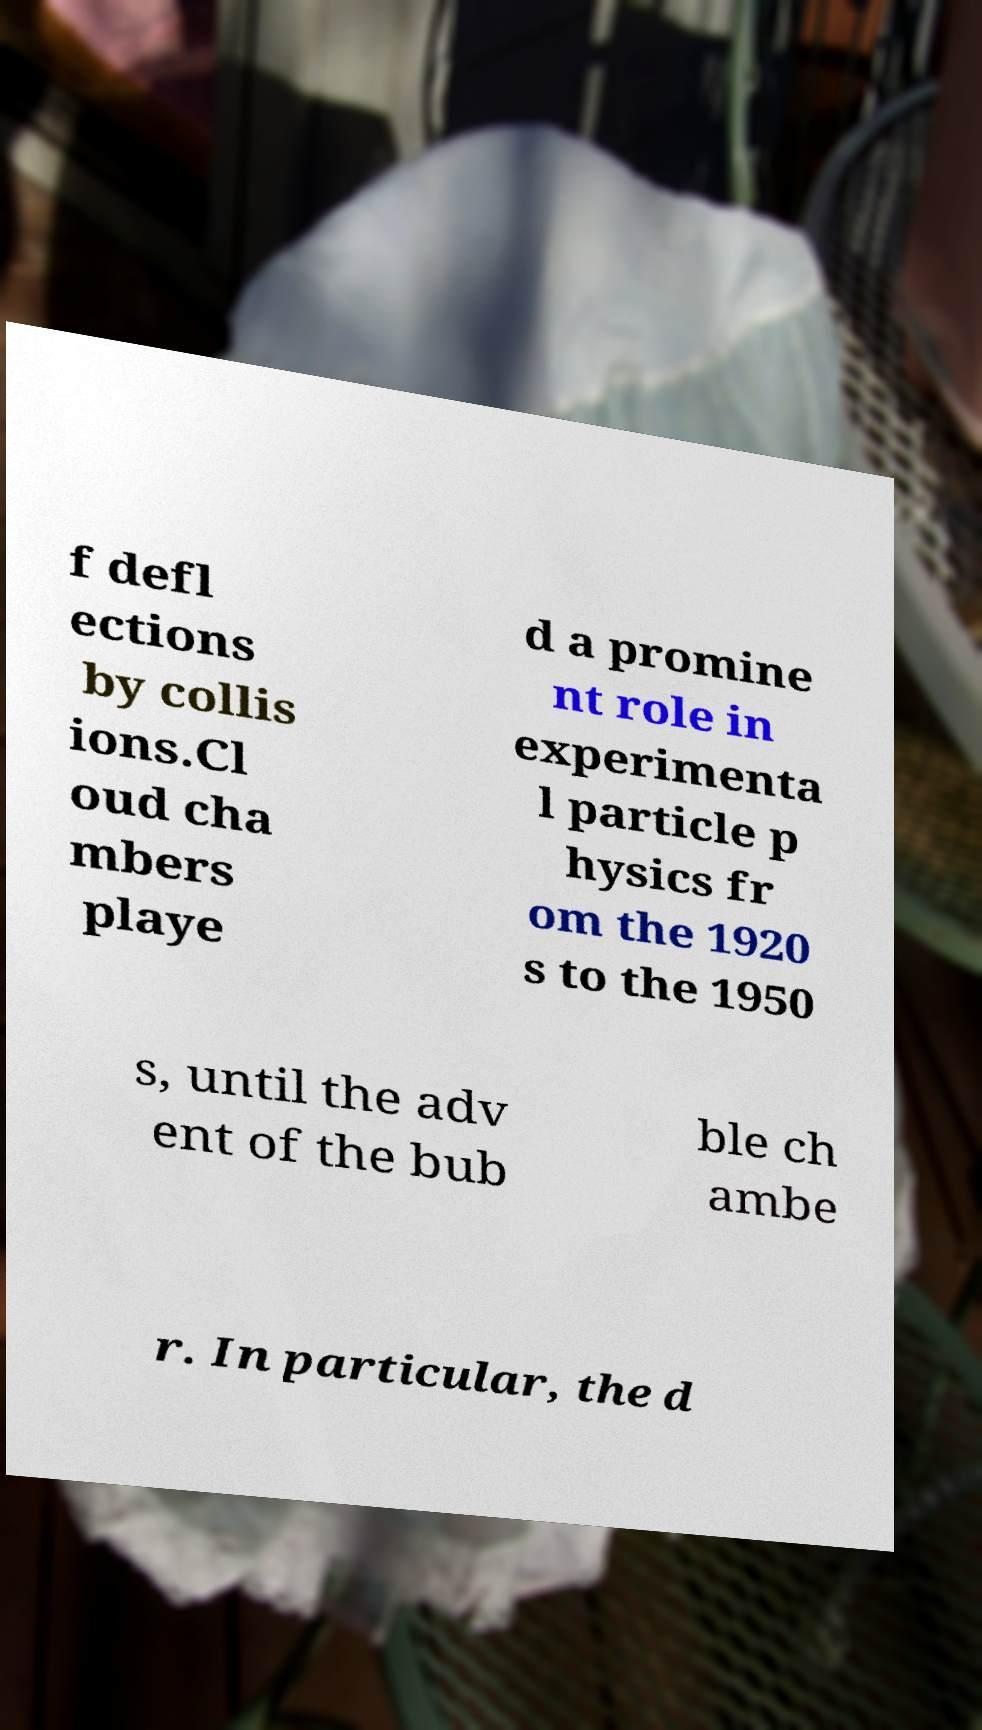I need the written content from this picture converted into text. Can you do that? f defl ections by collis ions.Cl oud cha mbers playe d a promine nt role in experimenta l particle p hysics fr om the 1920 s to the 1950 s, until the adv ent of the bub ble ch ambe r. In particular, the d 